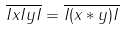<formula> <loc_0><loc_0><loc_500><loc_500>\overline { I x I y I } = \overline { I ( x \ast y ) I }</formula> 